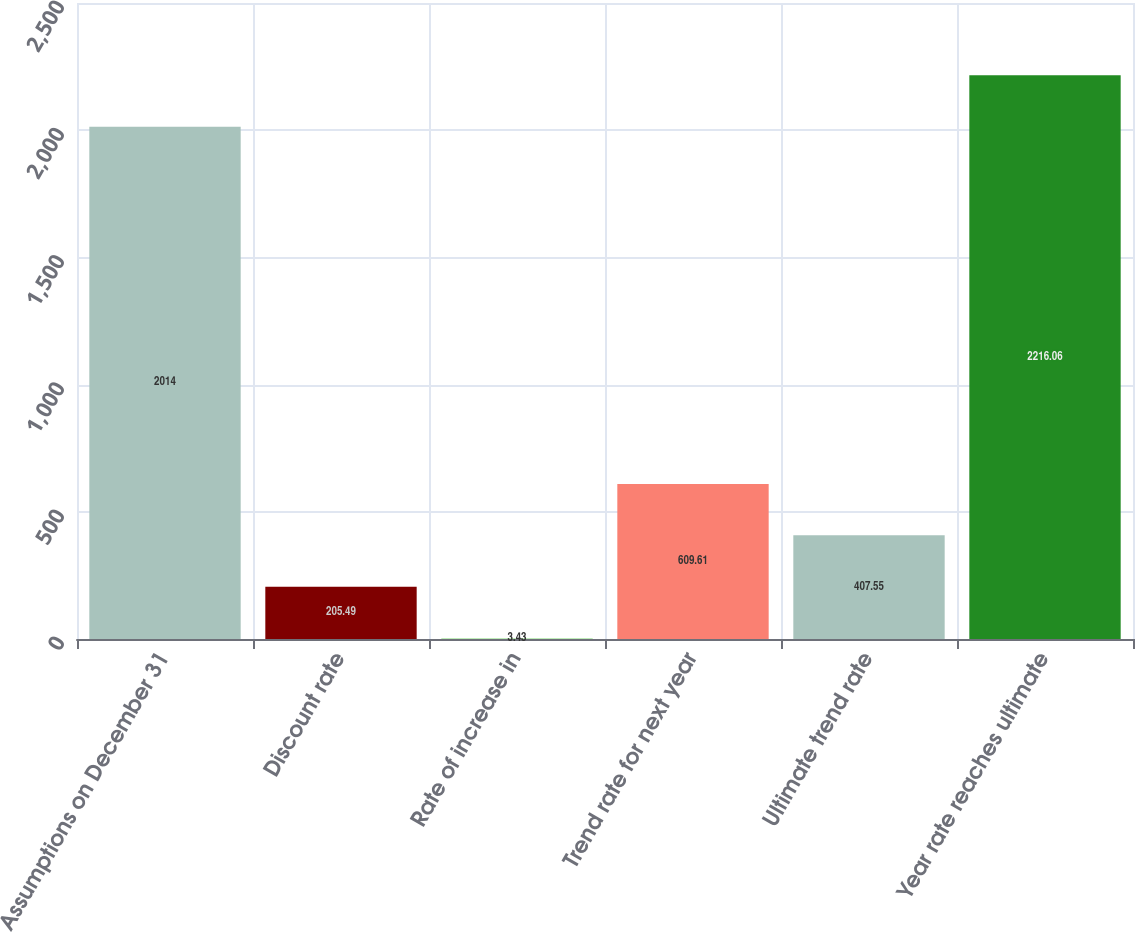Convert chart to OTSL. <chart><loc_0><loc_0><loc_500><loc_500><bar_chart><fcel>Assumptions on December 31<fcel>Discount rate<fcel>Rate of increase in<fcel>Trend rate for next year<fcel>Ultimate trend rate<fcel>Year rate reaches ultimate<nl><fcel>2014<fcel>205.49<fcel>3.43<fcel>609.61<fcel>407.55<fcel>2216.06<nl></chart> 